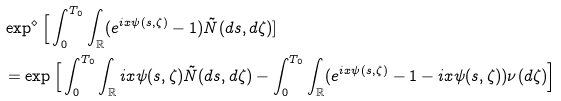<formula> <loc_0><loc_0><loc_500><loc_500>& \exp ^ { \diamond } \Big [ \int _ { 0 } ^ { T _ { 0 } } \int _ { \mathbb { R } } ( e ^ { i x \psi ( s , \zeta ) } - 1 ) \tilde { N } ( d s , d \zeta ) ] \\ & = \exp \Big [ \int _ { 0 } ^ { T _ { 0 } } \int _ { \mathbb { R } } i x \psi ( s , \zeta ) \tilde { N } ( d s , d \zeta ) - \int _ { 0 } ^ { T _ { 0 } } \int _ { \mathbb { R } } ( e ^ { i x \psi ( s , \zeta ) } - 1 - i x \psi ( s , \zeta ) ) \nu ( d \zeta ) \Big ]</formula> 